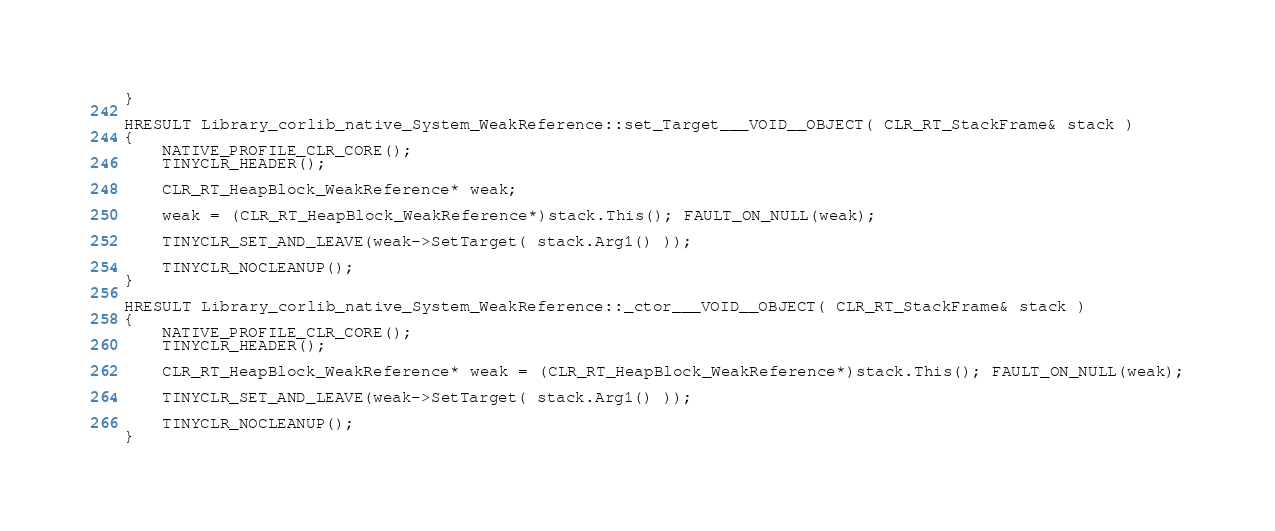<code> <loc_0><loc_0><loc_500><loc_500><_C++_>}

HRESULT Library_corlib_native_System_WeakReference::set_Target___VOID__OBJECT( CLR_RT_StackFrame& stack )
{
    NATIVE_PROFILE_CLR_CORE();
    TINYCLR_HEADER();

    CLR_RT_HeapBlock_WeakReference* weak;

    weak = (CLR_RT_HeapBlock_WeakReference*)stack.This(); FAULT_ON_NULL(weak);

    TINYCLR_SET_AND_LEAVE(weak->SetTarget( stack.Arg1() ));

    TINYCLR_NOCLEANUP();
}

HRESULT Library_corlib_native_System_WeakReference::_ctor___VOID__OBJECT( CLR_RT_StackFrame& stack )
{
    NATIVE_PROFILE_CLR_CORE();
    TINYCLR_HEADER();

    CLR_RT_HeapBlock_WeakReference* weak = (CLR_RT_HeapBlock_WeakReference*)stack.This(); FAULT_ON_NULL(weak);

    TINYCLR_SET_AND_LEAVE(weak->SetTarget( stack.Arg1() ));

    TINYCLR_NOCLEANUP();
}
</code> 